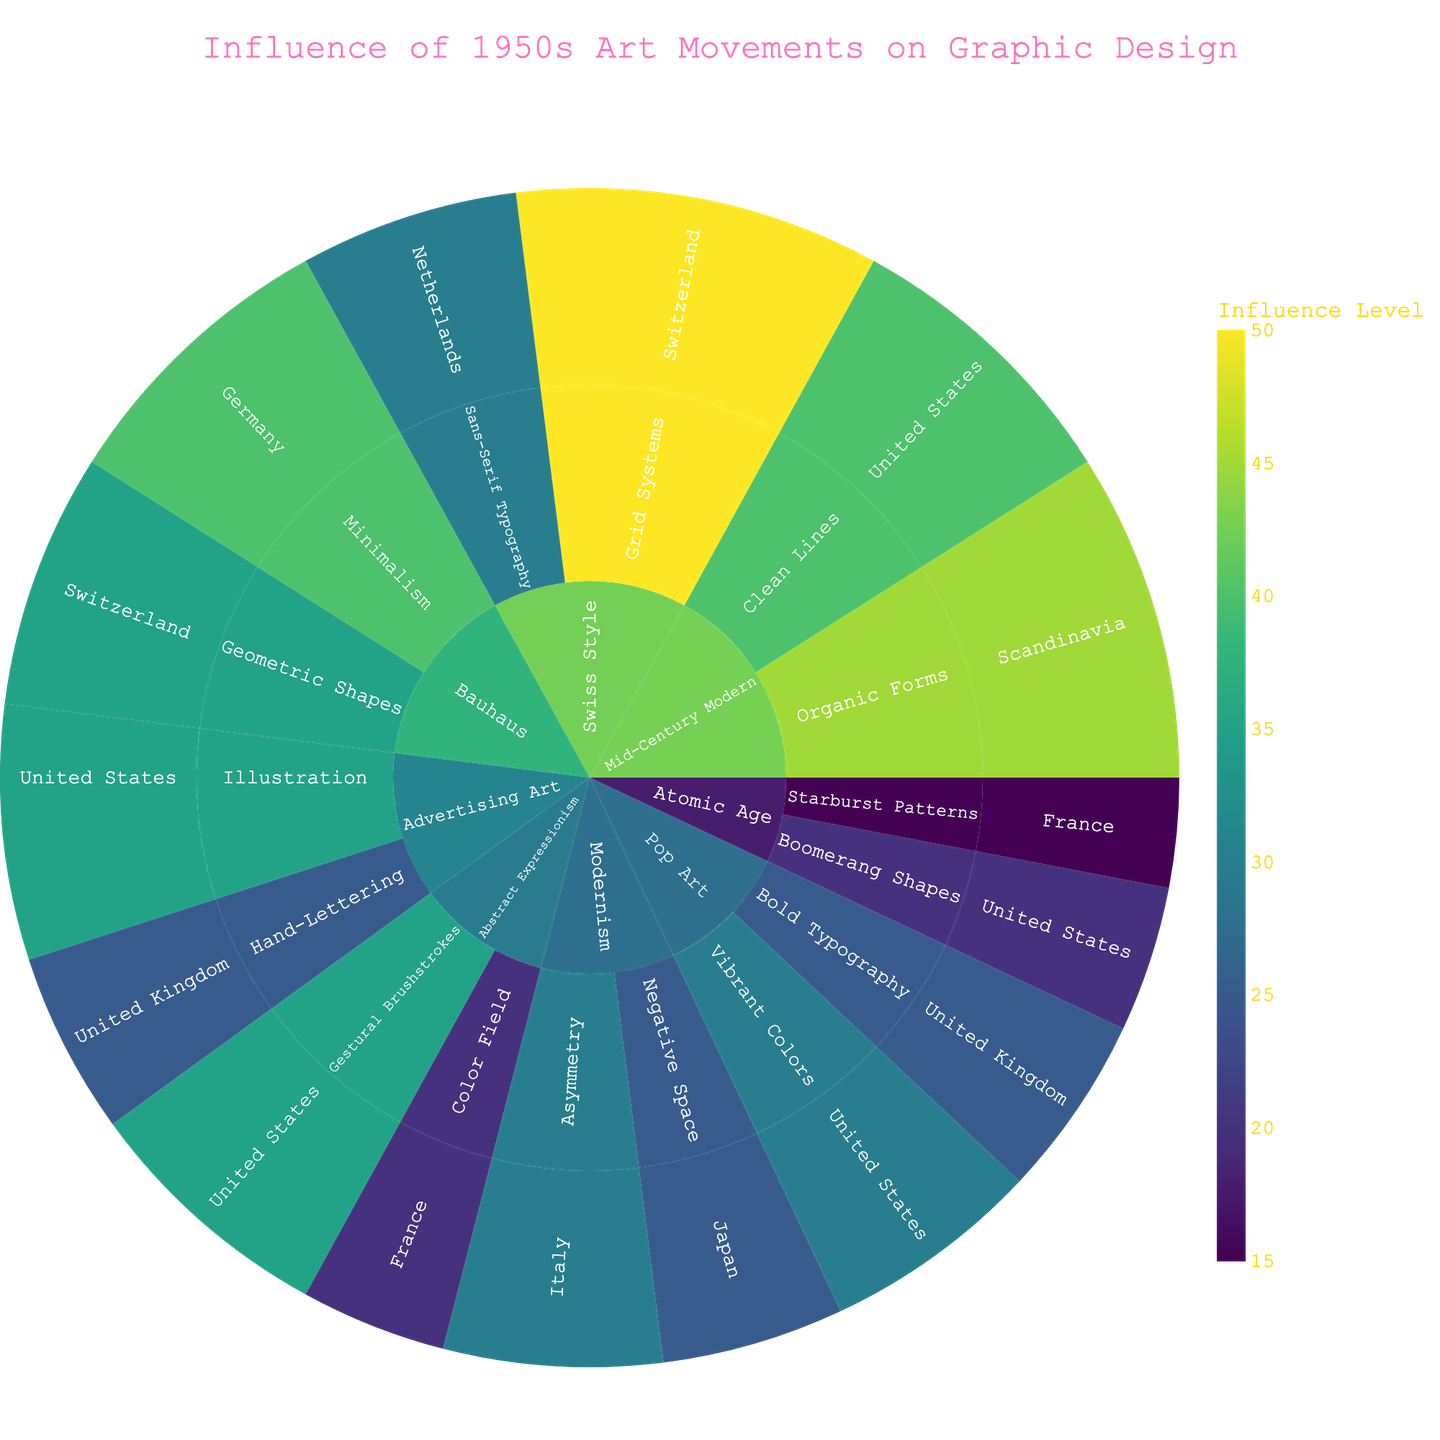Which art movement has the highest influence in Germany? The sunburst plot shows the influence levels categorized by art movement, style, and region. By looking at the different regions under each art movement, we see that Bauhaus has a high influence (40) in Germany.
Answer: Bauhaus In which country does Pop Art have the greatest influence? Following the regions under Pop Art, United States has the highest influence (30) compared to the United Kingdom (25).
Answer: United States What is the combined influence of Abstract Expressionism in the United States and France? The influence of Abstract Expressionism is displayed for different countries, with 35 for the United States and 20 for France. Adding these together: 35 + 20 = 55.
Answer: 55 Which style under Mid-Century Modern has a higher influence in the United States? The sunburst plot shows two styles under Mid-Century Modern in the United States: Organic Forms (45) and Clean Lines (40). Organic Forms has a higher influence.
Answer: Organic Forms Compare the influence of Swiss Style in Switzerland and Netherlands. Which one is higher and by how much? For Swiss Style, Switzerland has an influence of 50, and Netherlands has an influence of 30. The difference is: 50 – 30 = 20. Switzerland has a higher influence by 20.
Answer: Switzerland, by 20 Which art movement shows the influence in both United States and France? By examining the plot, we see that both Abstract Expressionism shows influences in United States (35) and France (20).
Answer: Abstract Expressionism What is the influence level of the style with the highest influence in the plot? The plot exhibits the influence levels, and the highest one is 50, which corresponds to the Grid Systems under Swiss Style in Switzerland.
Answer: 50 Identify the art movement and style with the lowest influence level in France. Scanning through the categories in France, Atomic Age with Starburst Patterns has the lowest influence level of 15.
Answer: Atomic Age, Starburst Patterns How many unique regions are represented in the Bauhaus art movement? The sunburst plot shows regions under each art movement, with Bauhaus having influence in Germany and Switzerland. Two unique regions are represented.
Answer: 2 